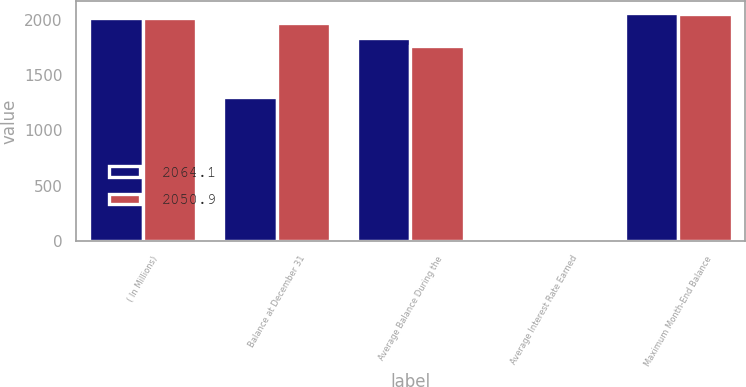Convert chart to OTSL. <chart><loc_0><loc_0><loc_500><loc_500><stacked_bar_chart><ecel><fcel>( In Millions)<fcel>Balance at December 31<fcel>Average Balance During the<fcel>Average Interest Rate Earned<fcel>Maximum Month-End Balance<nl><fcel>2064.1<fcel>2017<fcel>1303.3<fcel>1832<fcel>1.48<fcel>2064.1<nl><fcel>2050.9<fcel>2016<fcel>1967.5<fcel>1764.1<fcel>1.04<fcel>2050.9<nl></chart> 